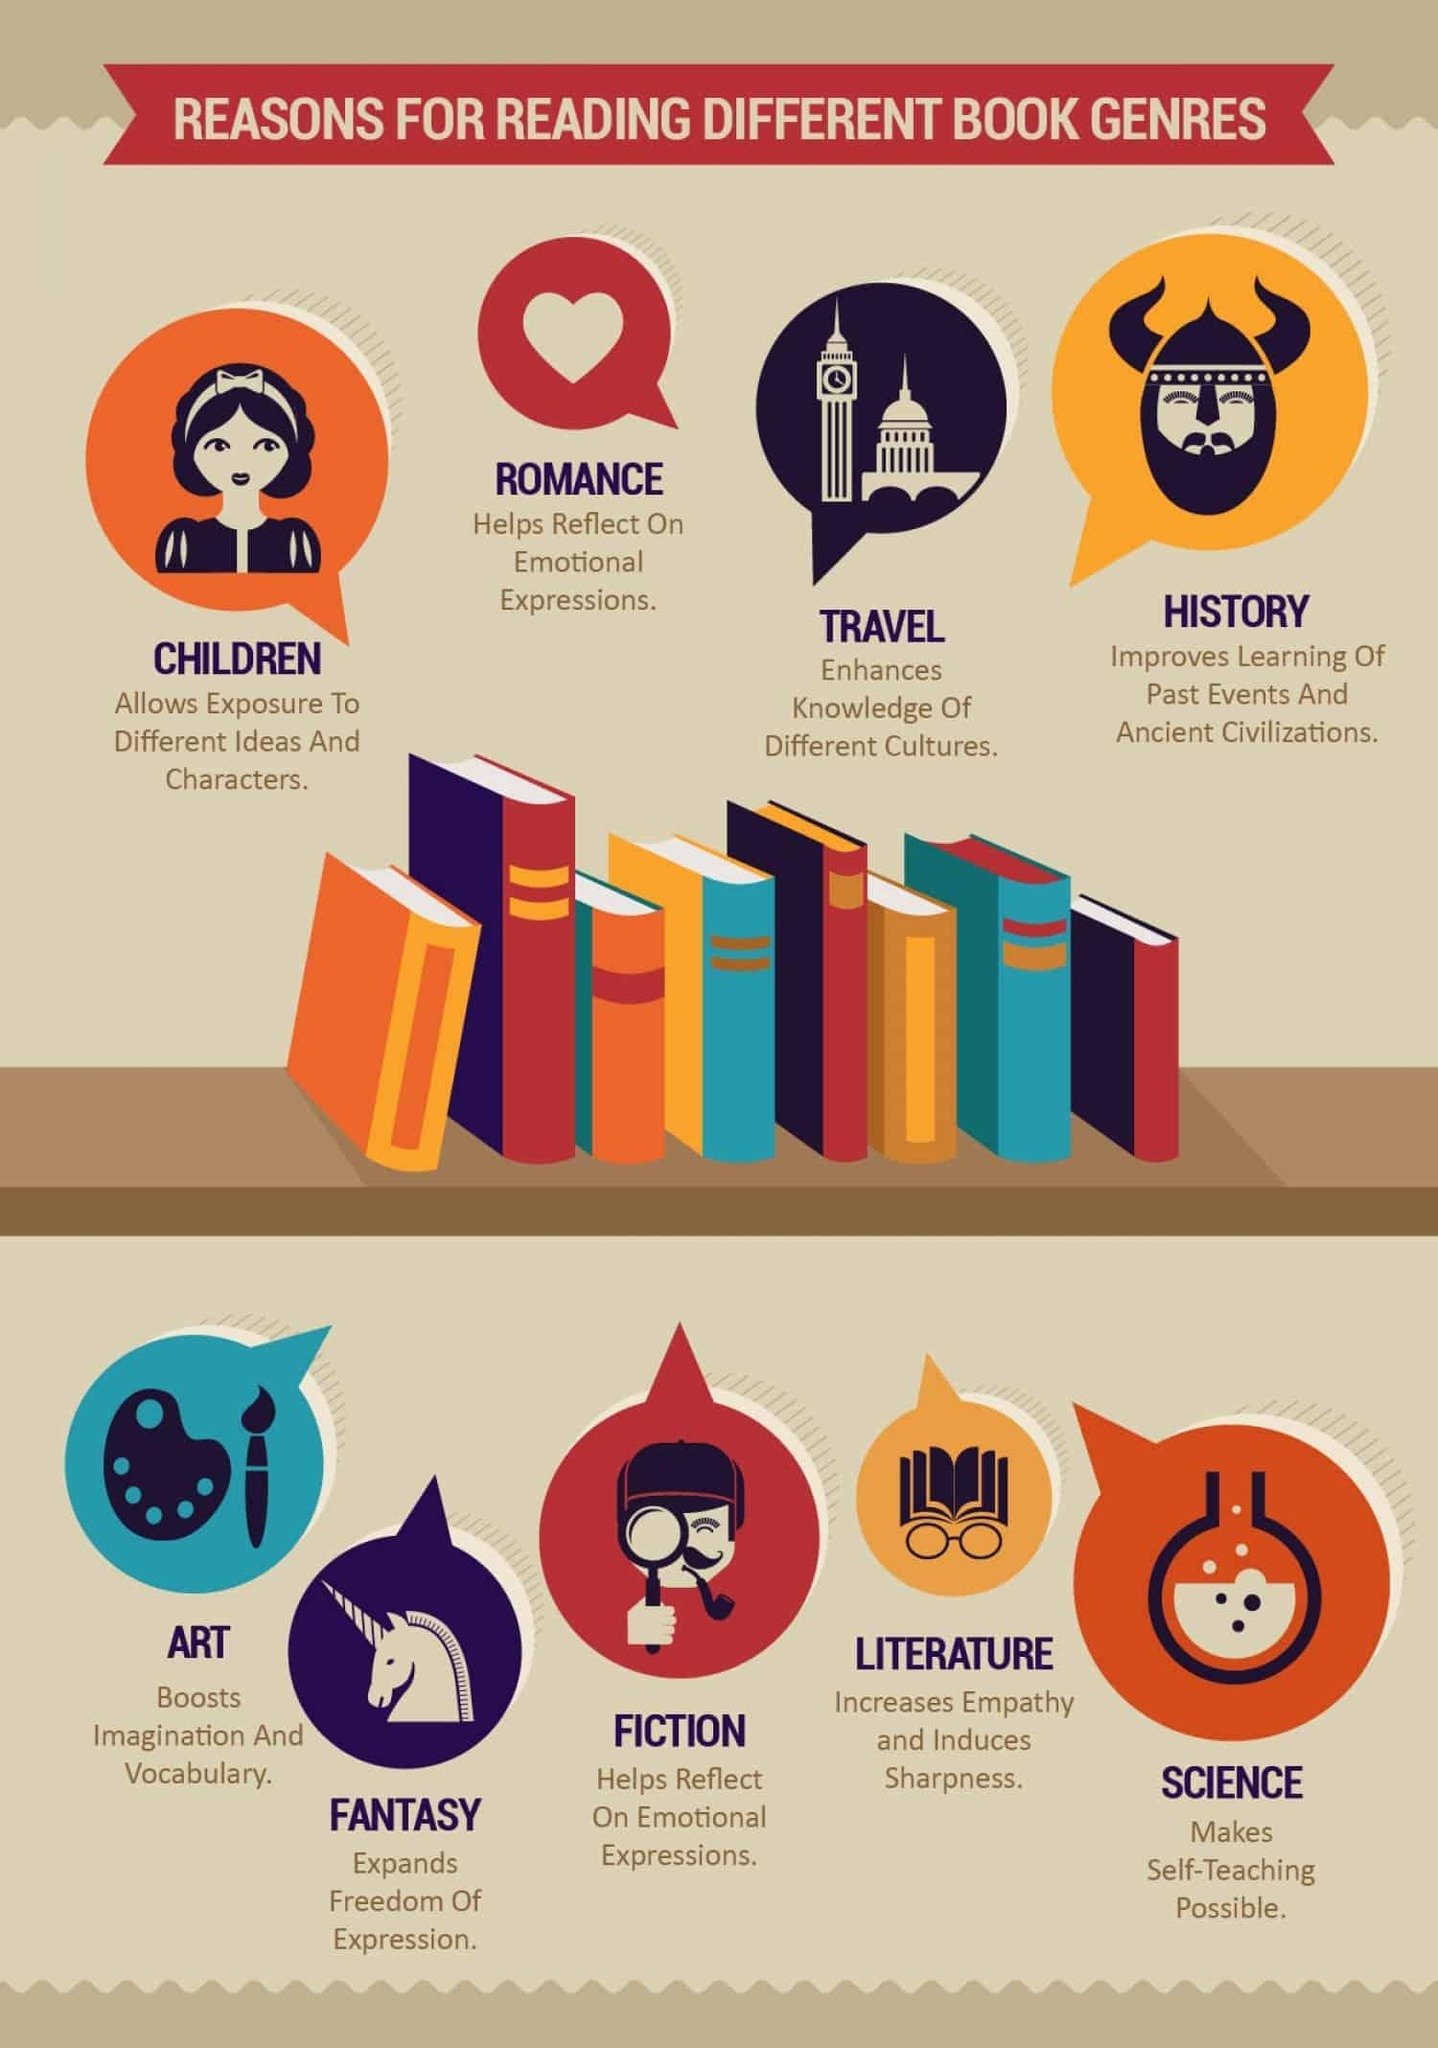Which genre is represented by heart symbol?
Answer the question with a short phrase. romance Which is the second last genre given in this infographic? literature how many different genres are given in this infographic? 9 which genre seems to boost imagination? art which genre seems to increase empathy? literature 